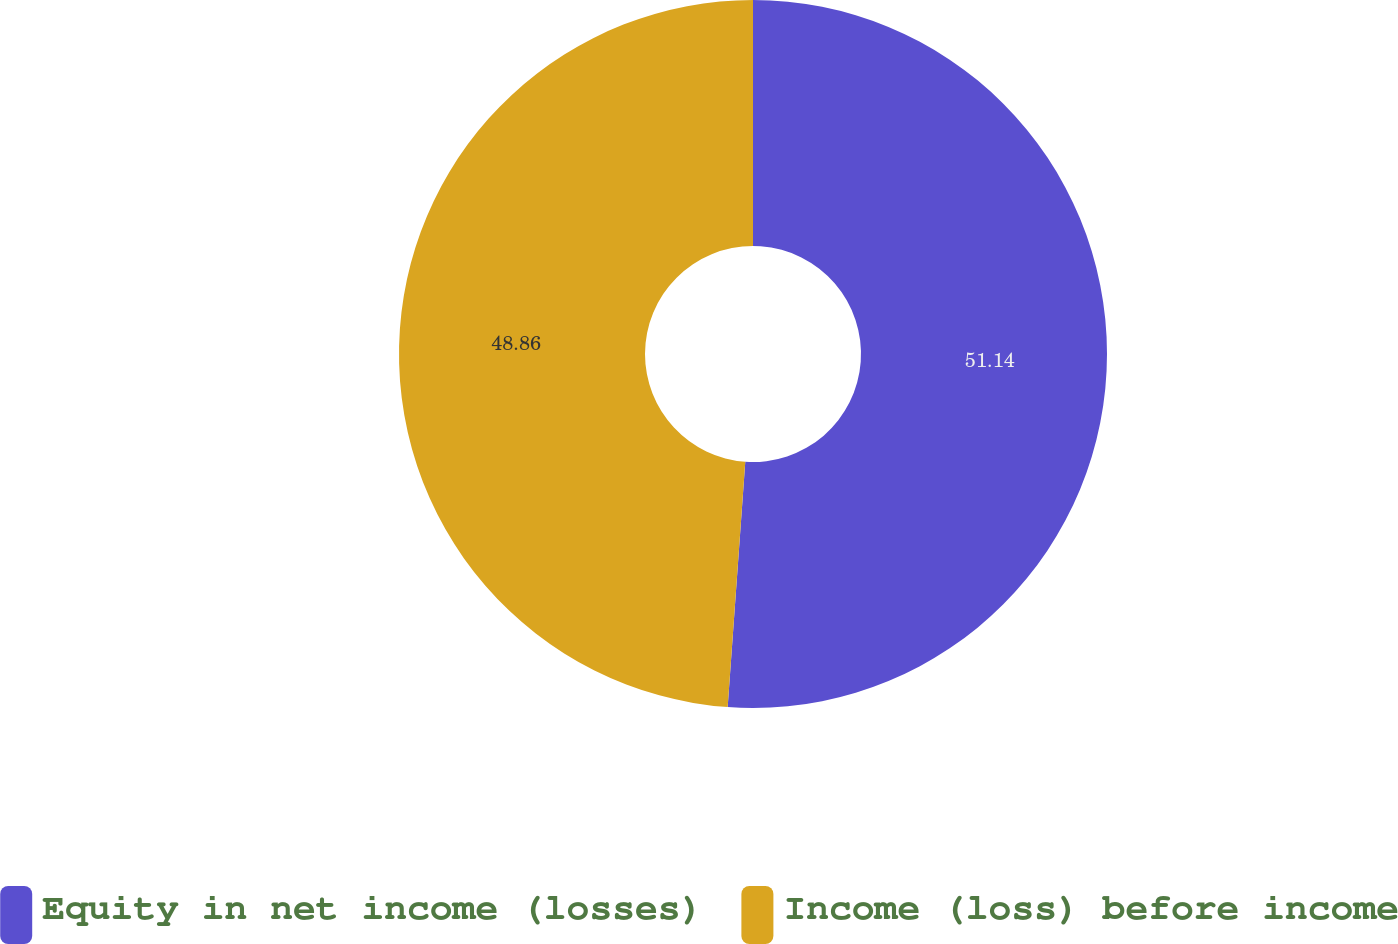Convert chart to OTSL. <chart><loc_0><loc_0><loc_500><loc_500><pie_chart><fcel>Equity in net income (losses)<fcel>Income (loss) before income<nl><fcel>51.14%<fcel>48.86%<nl></chart> 